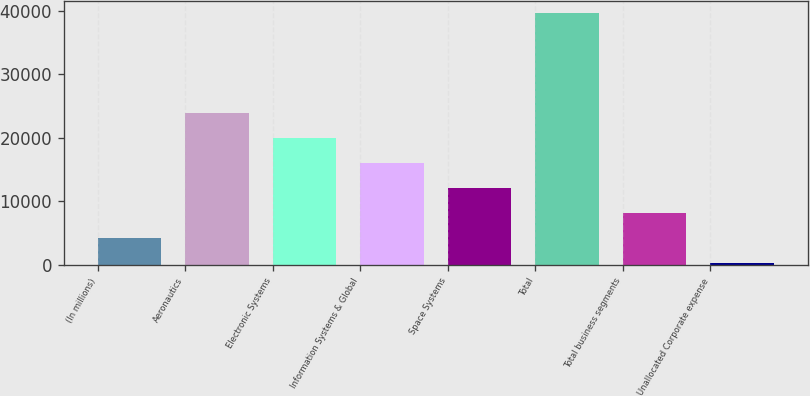Convert chart. <chart><loc_0><loc_0><loc_500><loc_500><bar_chart><fcel>(In millions)<fcel>Aeronautics<fcel>Electronic Systems<fcel>Information Systems & Global<fcel>Space Systems<fcel>Total<fcel>Total business segments<fcel>Unallocated Corporate expense<nl><fcel>4196.9<fcel>23876.4<fcel>19940.5<fcel>16004.6<fcel>12068.7<fcel>39620<fcel>8132.8<fcel>261<nl></chart> 